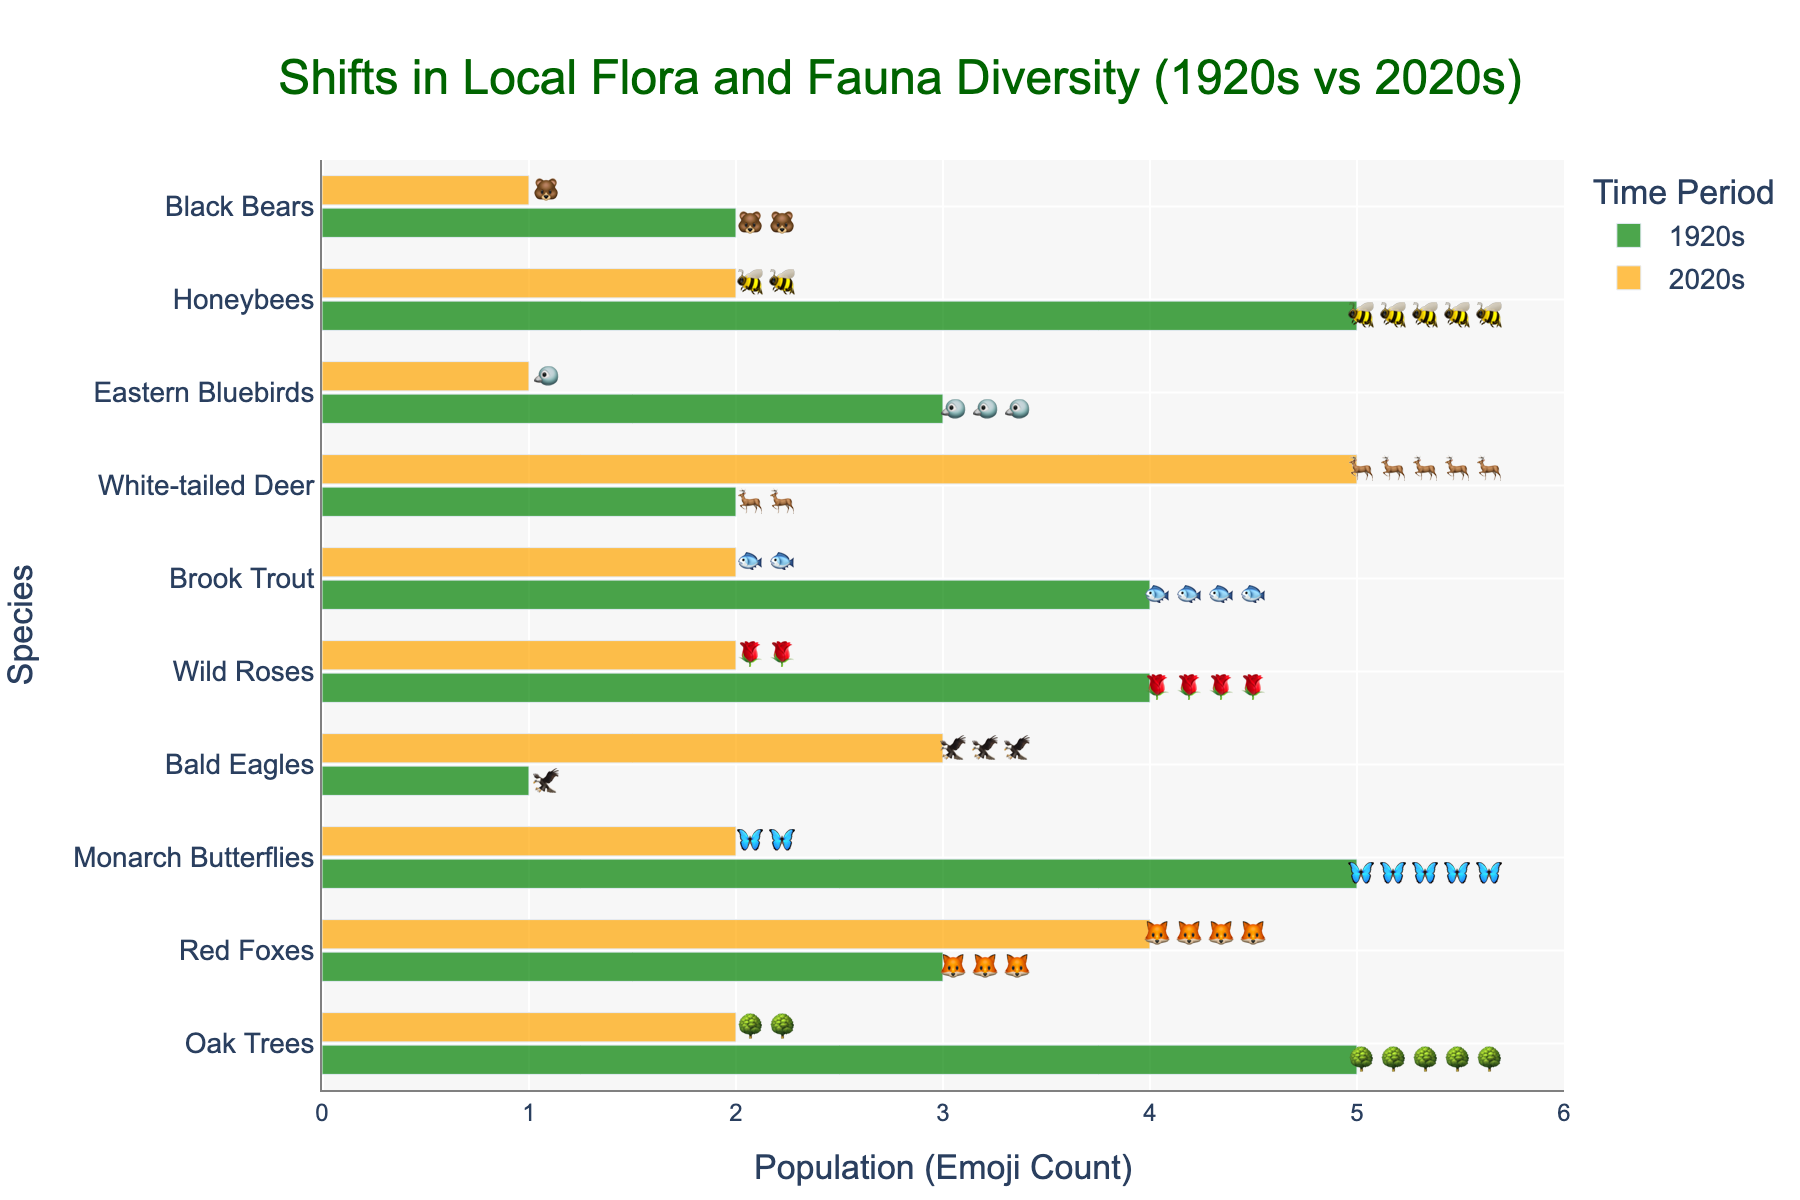What is the title of the figure? The title is located at the top of the figure and provides a summary of the content being represented.
Answer: Shifts in Local Flora and Fauna Diversity (1920s vs 2020s) Which species has the most increase in emoji count from the 1920s to the 2020s? Compare the emoji counts for each species between the 1920s and the 2020s and find the one with the greatest increase.
Answer: White-tailed Deer How many species have a decrease in emoji count from the 1920s to the 2020s? Compare the counts for each species between the two periods and count how many have fewer emojis in the 2020s.
Answer: 5 What is the total emoji count for all species in the 1920s? Sum up the emoji counts for all species in the 1920s.
Answer: 32 Which species has the same emoji count in both the 1920s and the 2020s? Identify the species where the counts for the 1920s and the 2020s are the same.
Answer: Red Foxes What is the average emoji count for species in the 2020s? Sum up the emoji counts for all species in the 2020s and divide by the number of species. The sum is 2+4+2+3+2+2+5+1+2+1 = 24, and there are 10 species, so the average is 24/10.
Answer: 2.4 Which species has the most significant decline in emoji count from the 1920s to the 2020s? Compare the emoji counts for each species between the two periods and find the one with the greatest decline.
Answer: Oak Trees How many species have an emoji count of exactly 2 in the 2020s? Count the number of species where the emoji count in the 2020s is exactly 2.
Answer: 4 Which species appears last in the y-axis list? Look at the species listed at the bottom of the y-axis on the figure.
Answer: Black Bears 